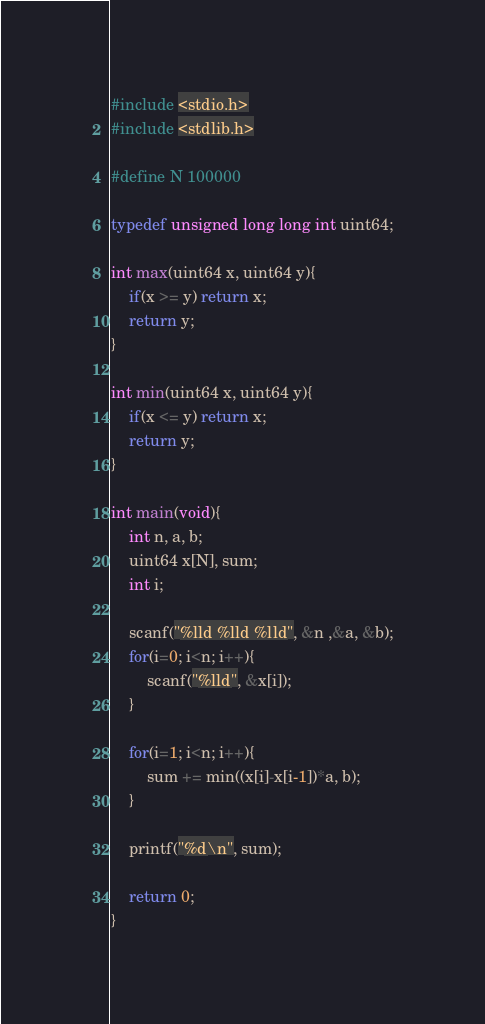<code> <loc_0><loc_0><loc_500><loc_500><_C_>#include <stdio.h>
#include <stdlib.h>

#define N 100000

typedef unsigned long long int uint64;

int max(uint64 x, uint64 y){
	if(x >= y) return x;
	return y;
}

int min(uint64 x, uint64 y){
	if(x <= y) return x;
	return y;
}

int main(void){
	int n, a, b;
	uint64 x[N], sum;
	int i;

	scanf("%lld %lld %lld", &n ,&a, &b);
	for(i=0; i<n; i++){
		scanf("%lld", &x[i]);
	}

	for(i=1; i<n; i++){
		sum += min((x[i]-x[i-1])*a, b);
	}

	printf("%d\n", sum);

	return 0;
}</code> 